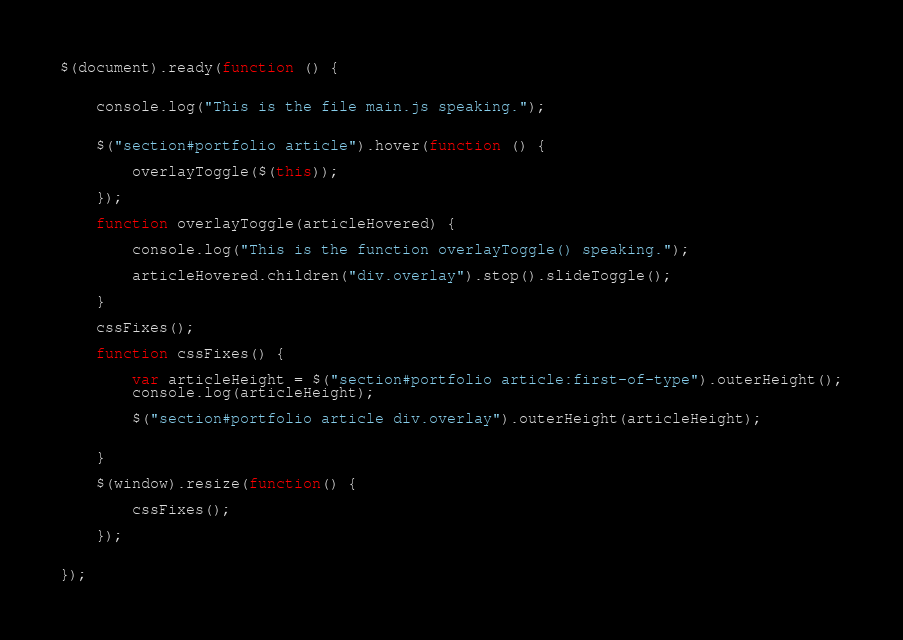<code> <loc_0><loc_0><loc_500><loc_500><_JavaScript_>$(document).ready(function () {


	console.log("This is the file main.js speaking.");


	$("section#portfolio article").hover(function () {

		overlayToggle($(this));

	});

	function overlayToggle(articleHovered) {

		console.log("This is the function overlayToggle() speaking.");

		articleHovered.children("div.overlay").stop().slideToggle();

	}

	cssFixes();

	function cssFixes() {

		var articleHeight = $("section#portfolio article:first-of-type").outerHeight();
		console.log(articleHeight);

		$("section#portfolio article div.overlay").outerHeight(articleHeight);


	}

	$(window).resize(function() {

		cssFixes();

	});


});

</code> 